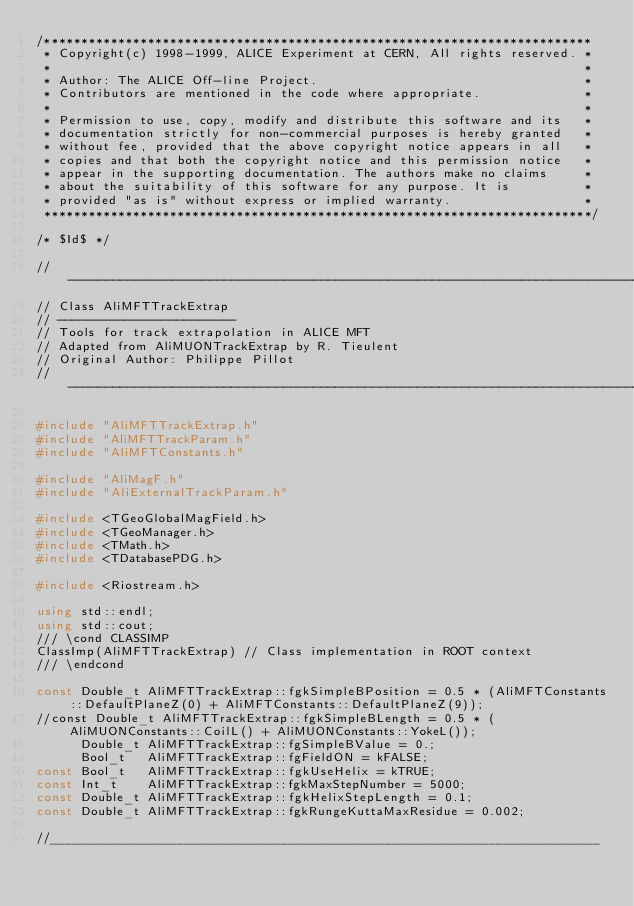<code> <loc_0><loc_0><loc_500><loc_500><_C++_>/**************************************************************************
 * Copyright(c) 1998-1999, ALICE Experiment at CERN, All rights reserved. *
 *                                                                        *
 * Author: The ALICE Off-line Project.                                    *
 * Contributors are mentioned in the code where appropriate.              *
 *                                                                        *
 * Permission to use, copy, modify and distribute this software and its   *
 * documentation strictly for non-commercial purposes is hereby granted   *
 * without fee, provided that the above copyright notice appears in all   *
 * copies and that both the copyright notice and this permission notice   *
 * appear in the supporting documentation. The authors make no claims     *
 * about the suitability of this software for any purpose. It is          *
 * provided "as is" without express or implied warranty.                  *
 **************************************************************************/

/* $Id$ */

//-----------------------------------------------------------------------------
// Class AliMFTTrackExtrap
// ------------------------
// Tools for track extrapolation in ALICE MFT
// Adapted from AliMUONTrackExtrap by R. Tieulent
// Original Author: Philippe Pillot
//-----------------------------------------------------------------------------

#include "AliMFTTrackExtrap.h"  
#include "AliMFTTrackParam.h"
#include "AliMFTConstants.h"

#include "AliMagF.h"
#include "AliExternalTrackParam.h"

#include <TGeoGlobalMagField.h>
#include <TGeoManager.h>
#include <TMath.h>
#include <TDatabasePDG.h>

#include <Riostream.h>

using std::endl;
using std::cout;
/// \cond CLASSIMP
ClassImp(AliMFTTrackExtrap) // Class implementation in ROOT context
/// \endcond

const Double_t AliMFTTrackExtrap::fgkSimpleBPosition = 0.5 * (AliMFTConstants::DefaultPlaneZ(0) + AliMFTConstants::DefaultPlaneZ(9));
//const Double_t AliMFTTrackExtrap::fgkSimpleBLength = 0.5 * (AliMUONConstants::CoilL() + AliMUONConstants::YokeL());
      Double_t AliMFTTrackExtrap::fgSimpleBValue = 0.;
      Bool_t   AliMFTTrackExtrap::fgFieldON = kFALSE;
const Bool_t   AliMFTTrackExtrap::fgkUseHelix = kTRUE;
const Int_t    AliMFTTrackExtrap::fgkMaxStepNumber = 5000;
const Double_t AliMFTTrackExtrap::fgkHelixStepLength = 0.1;
const Double_t AliMFTTrackExtrap::fgkRungeKuttaMaxResidue = 0.002;

//__________________________________________________________________________</code> 